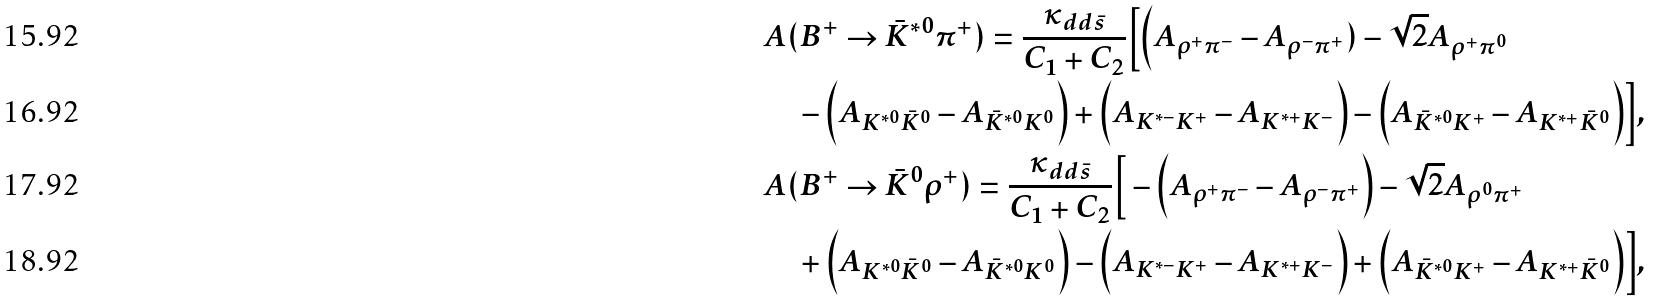<formula> <loc_0><loc_0><loc_500><loc_500>& A ( B ^ { + } \to \bar { K } ^ { * 0 } \pi ^ { + } ) = \frac { \kappa _ { d d \bar { s } } } { C _ { 1 } + C _ { 2 } } \Big [ \Big ( A _ { \rho ^ { + } \pi ^ { - } } - A _ { \rho ^ { - } \pi ^ { + } } ) - \sqrt { 2 } A _ { \rho ^ { + } \pi ^ { 0 } } \\ & \quad - \Big ( A _ { K ^ { * 0 } \bar { K } ^ { 0 } } - A _ { \bar { K } ^ { * 0 } K ^ { 0 } } \Big ) + \Big ( A _ { K ^ { * - } K ^ { + } } - A _ { K ^ { * + } K ^ { - } } \Big ) - \Big ( A _ { \bar { K } ^ { * 0 } K ^ { + } } - A _ { K ^ { * + } \bar { K } ^ { 0 } } \Big ) \Big ] , \\ & A ( B ^ { + } \to \bar { K } ^ { 0 } \rho ^ { + } ) = \frac { \kappa _ { d d \bar { s } } } { C _ { 1 } + C _ { 2 } } \Big [ - \Big ( A _ { \rho ^ { + } \pi ^ { - } } - A _ { \rho ^ { - } \pi ^ { + } } \Big ) - \sqrt { 2 } A _ { \rho ^ { 0 } \pi ^ { + } } \\ & \quad + \Big ( A _ { K ^ { * 0 } \bar { K } ^ { 0 } } - A _ { \bar { K } ^ { * 0 } K ^ { 0 } } \Big ) - \Big ( A _ { K ^ { * - } K ^ { + } } - A _ { K ^ { * + } K ^ { - } } \Big ) + \Big ( A _ { \bar { K } ^ { * 0 } K ^ { + } } - A _ { K ^ { * + } \bar { K } ^ { 0 } } \Big ) \Big ] ,</formula> 